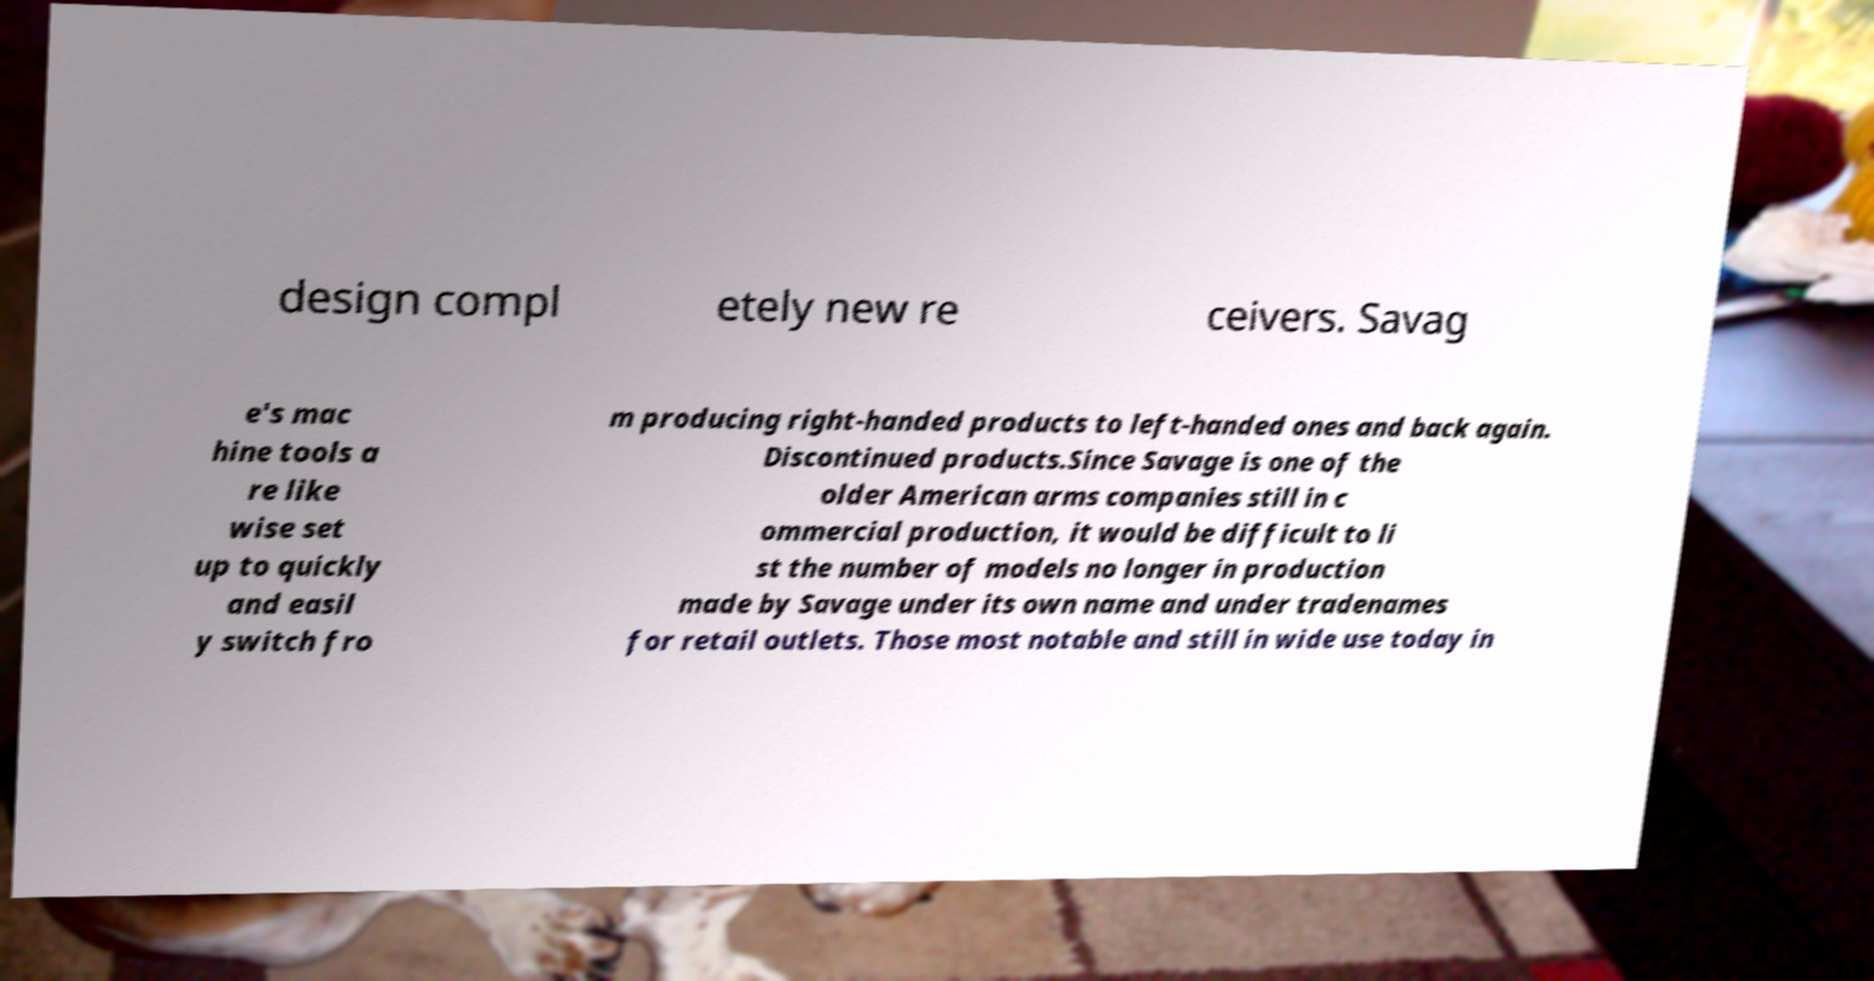For documentation purposes, I need the text within this image transcribed. Could you provide that? design compl etely new re ceivers. Savag e's mac hine tools a re like wise set up to quickly and easil y switch fro m producing right-handed products to left-handed ones and back again. Discontinued products.Since Savage is one of the older American arms companies still in c ommercial production, it would be difficult to li st the number of models no longer in production made by Savage under its own name and under tradenames for retail outlets. Those most notable and still in wide use today in 